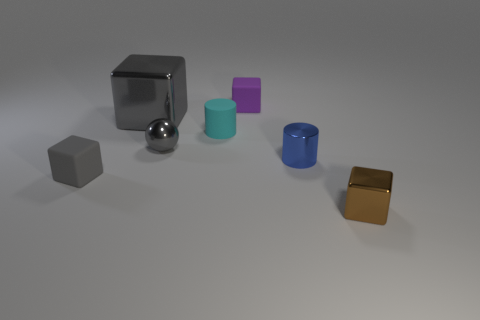There is a small ball that is the same color as the large object; what material is it?
Make the answer very short. Metal. How many objects are rubber things that are left of the small purple thing or gray metal things?
Provide a succinct answer. 4. Are there any small things?
Give a very brief answer. Yes. The thing that is both behind the metal sphere and to the left of the small metallic ball has what shape?
Your answer should be very brief. Cube. There is a gray metallic thing to the left of the tiny metallic sphere; what is its size?
Offer a very short reply. Large. Does the matte thing to the left of the large gray block have the same color as the large object?
Offer a terse response. Yes. How many other big gray things are the same shape as the large shiny thing?
Your response must be concise. 0. How many things are either small things that are behind the cyan object or tiny blocks behind the small gray matte thing?
Your response must be concise. 1. How many purple things are small spheres or small objects?
Give a very brief answer. 1. There is a tiny block that is behind the tiny metallic cube and right of the large metallic thing; what material is it made of?
Ensure brevity in your answer.  Rubber. 